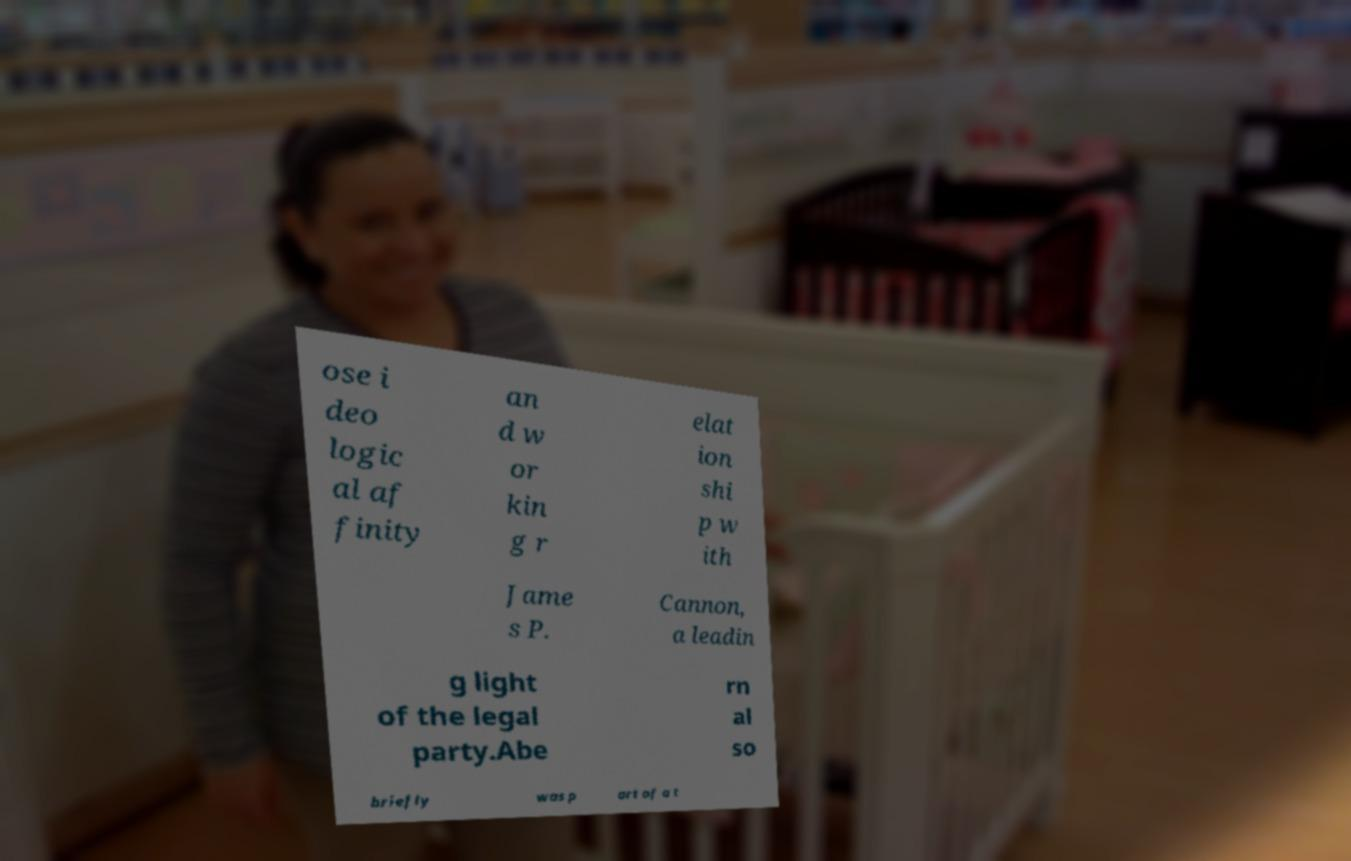What messages or text are displayed in this image? I need them in a readable, typed format. ose i deo logic al af finity an d w or kin g r elat ion shi p w ith Jame s P. Cannon, a leadin g light of the legal party.Abe rn al so briefly was p art of a t 